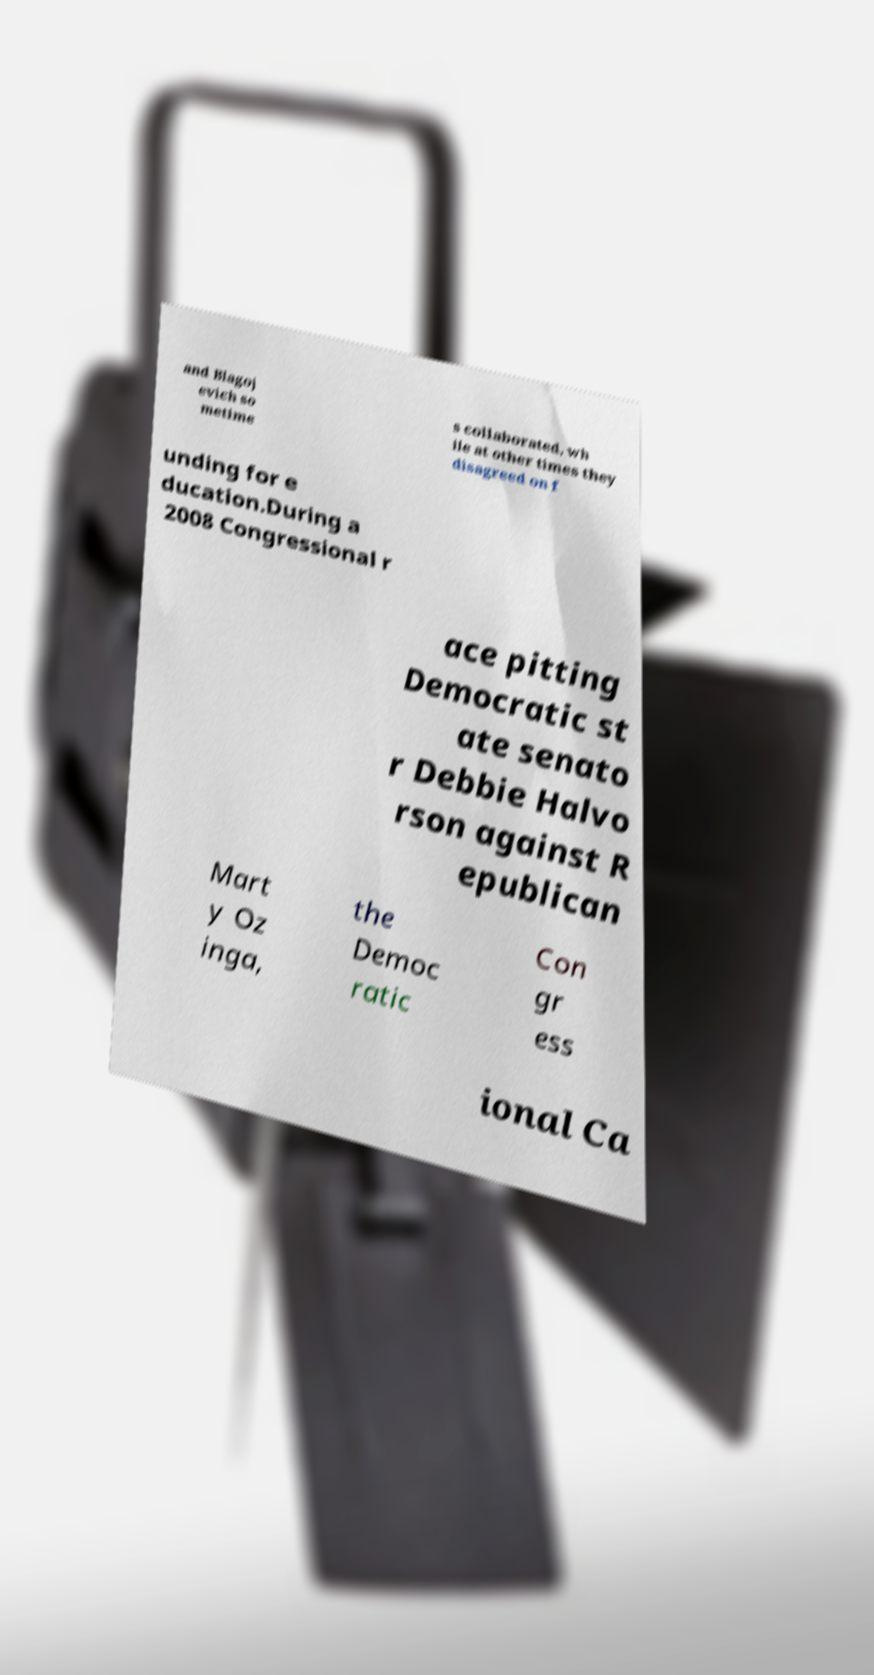For documentation purposes, I need the text within this image transcribed. Could you provide that? and Blagoj evich so metime s collaborated, wh ile at other times they disagreed on f unding for e ducation.During a 2008 Congressional r ace pitting Democratic st ate senato r Debbie Halvo rson against R epublican Mart y Oz inga, the Democ ratic Con gr ess ional Ca 